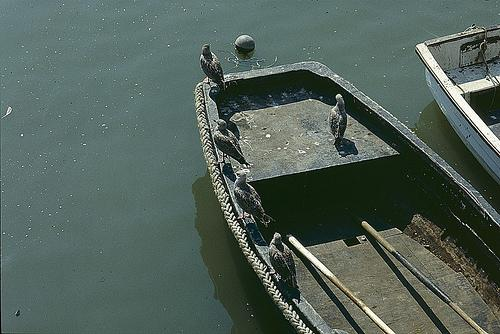What are the two long poles? Please explain your reasoning. oar handles. The boat depicted is a rowboat that would be propelled by answer and their shape and size is consistent. 